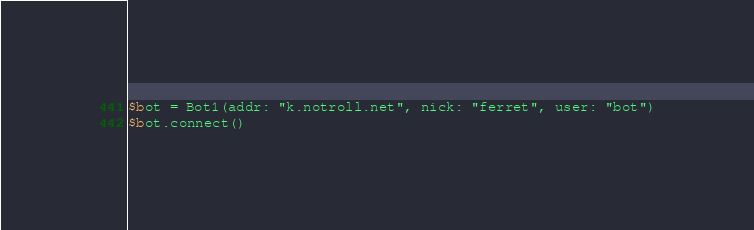Convert code to text. <code><loc_0><loc_0><loc_500><loc_500><_Forth_>$bot = Bot1(addr: "k.notroll.net", nick: "ferret", user: "bot")
$bot.connect()
</code> 